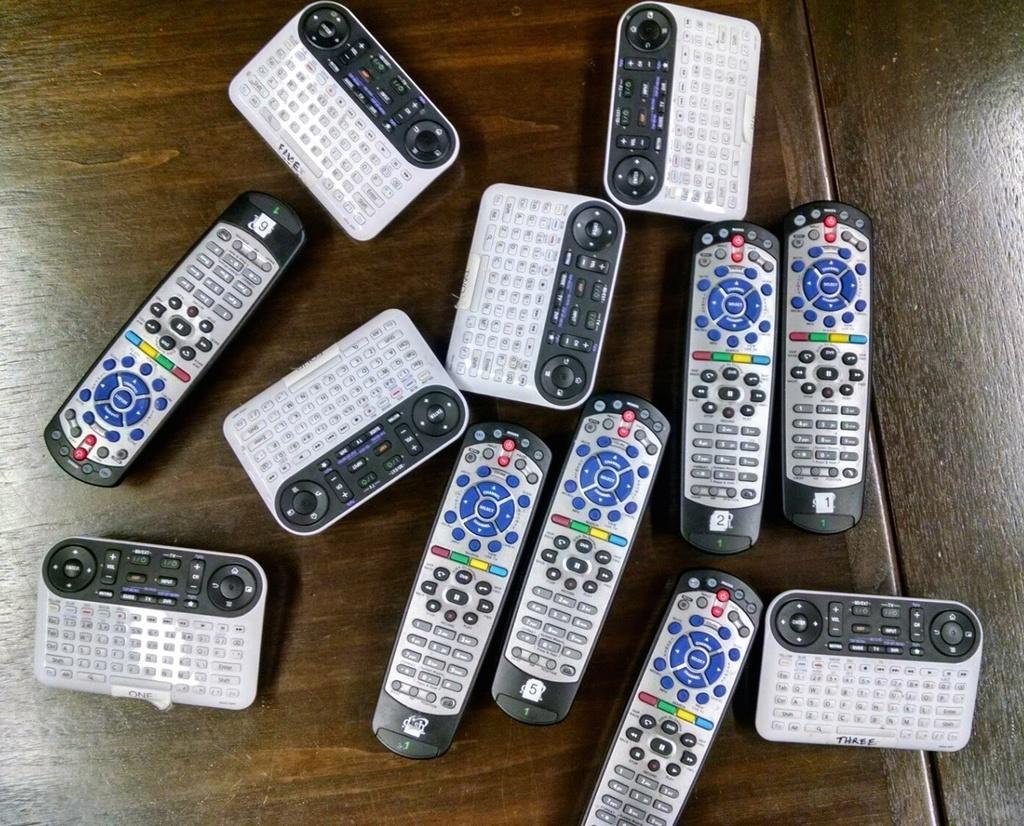<image>
Write a terse but informative summary of the picture. Table full of remote controllers including one that says THREE on the bottom. 